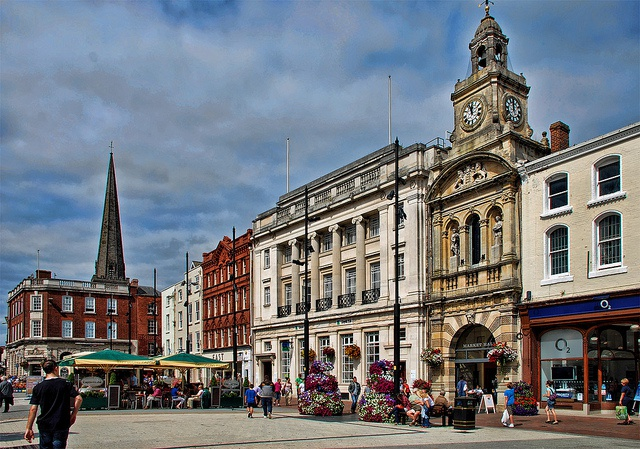Describe the objects in this image and their specific colors. I can see people in gray, black, maroon, and brown tones, people in gray, black, maroon, and brown tones, potted plant in gray, black, maroon, and darkgreen tones, umbrella in gray, teal, khaki, maroon, and black tones, and umbrella in gray, teal, khaki, olive, and brown tones in this image. 